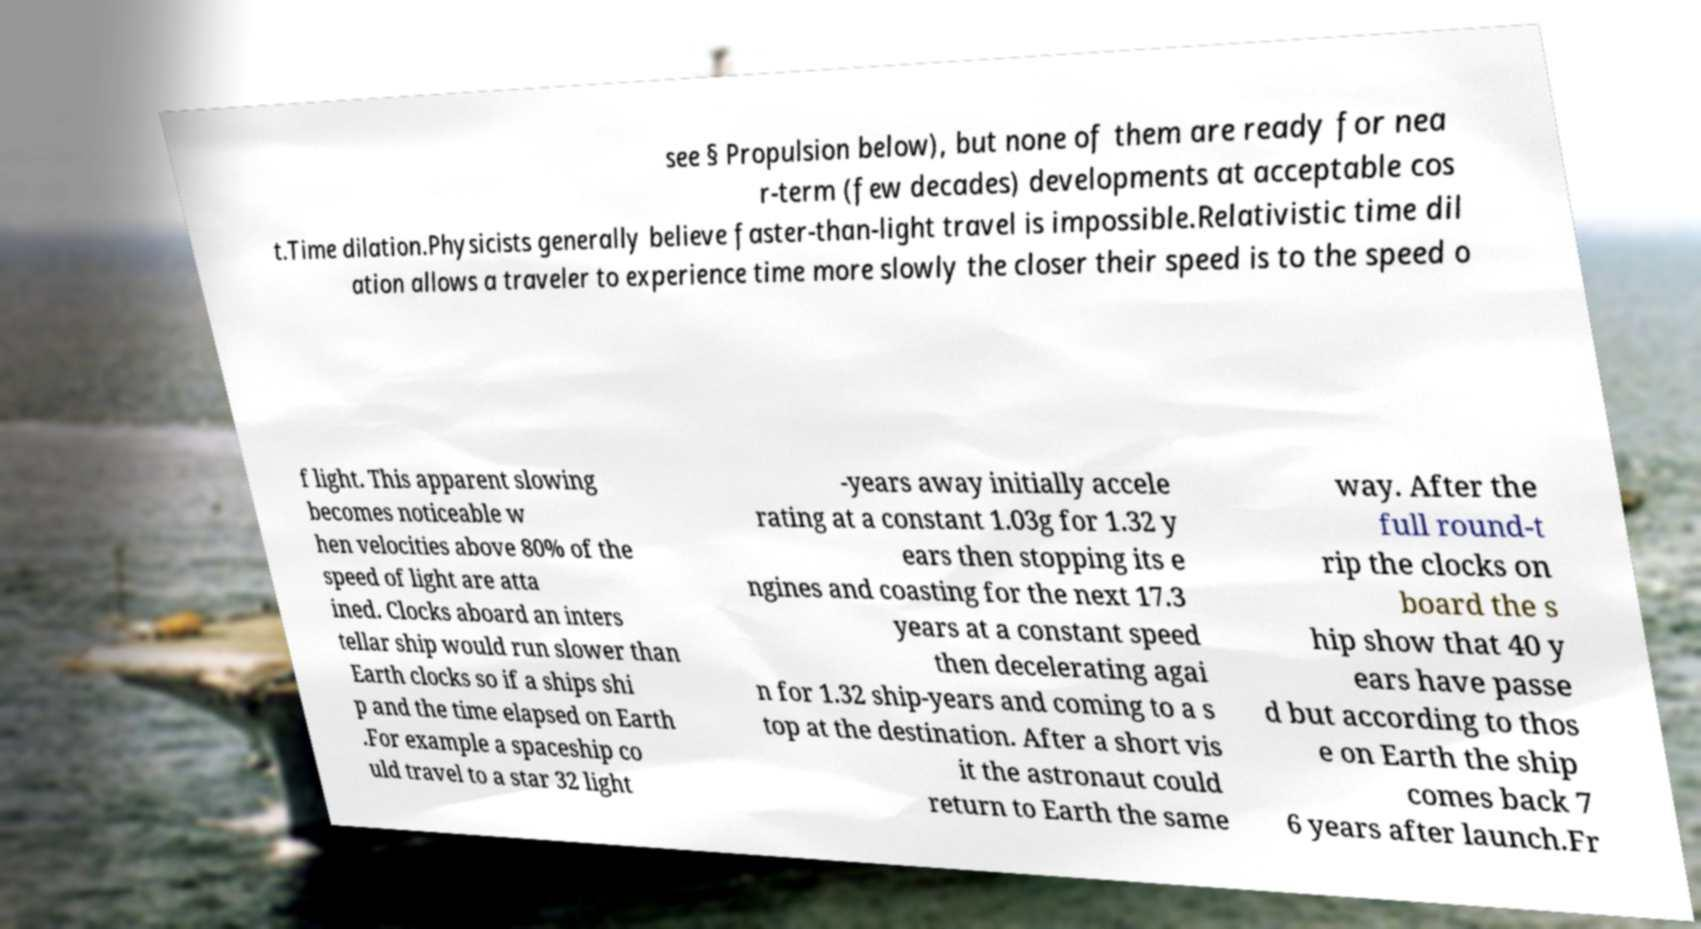Please identify and transcribe the text found in this image. see § Propulsion below), but none of them are ready for nea r-term (few decades) developments at acceptable cos t.Time dilation.Physicists generally believe faster-than-light travel is impossible.Relativistic time dil ation allows a traveler to experience time more slowly the closer their speed is to the speed o f light. This apparent slowing becomes noticeable w hen velocities above 80% of the speed of light are atta ined. Clocks aboard an inters tellar ship would run slower than Earth clocks so if a ships shi p and the time elapsed on Earth .For example a spaceship co uld travel to a star 32 light -years away initially accele rating at a constant 1.03g for 1.32 y ears then stopping its e ngines and coasting for the next 17.3 years at a constant speed then decelerating agai n for 1.32 ship-years and coming to a s top at the destination. After a short vis it the astronaut could return to Earth the same way. After the full round-t rip the clocks on board the s hip show that 40 y ears have passe d but according to thos e on Earth the ship comes back 7 6 years after launch.Fr 